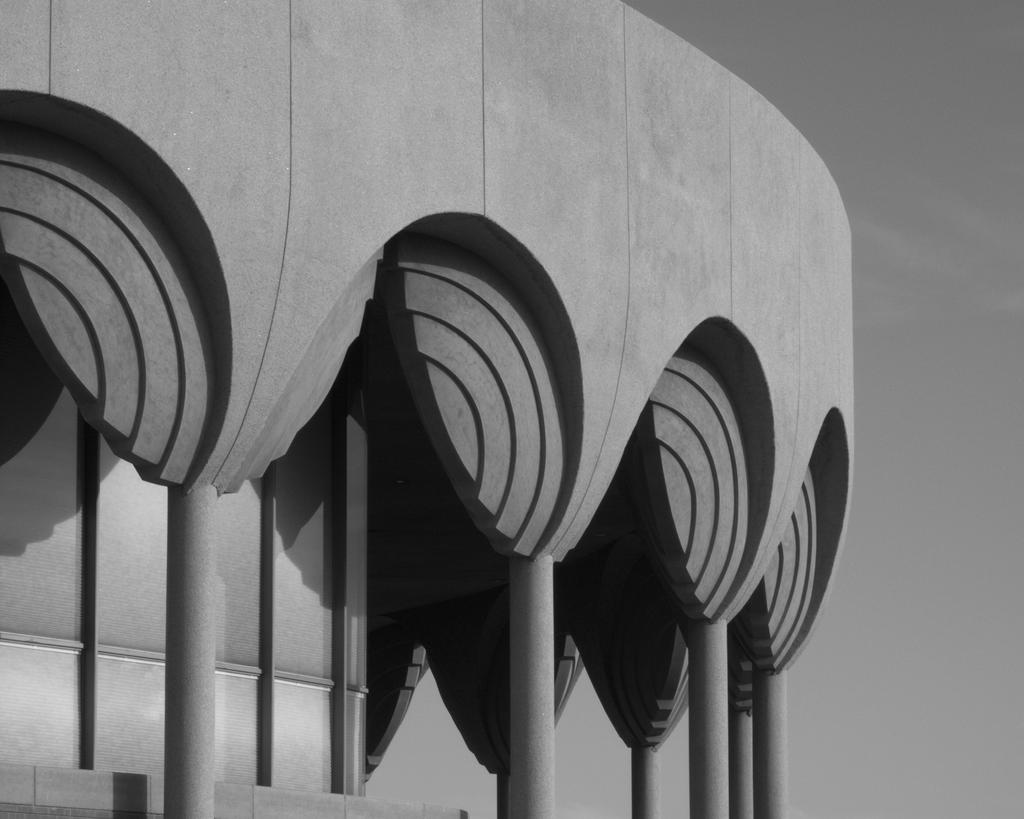What is the color scheme of the image? The image is black and white. What type of structure can be seen in the image? There is a building with pillars in the image. What can be seen in the background of the image? The sky is visible in the background of the image. How much debt is the building in the image responsible for? There is no information about the building's debt in the image, as it is not relevant to the visual content. 